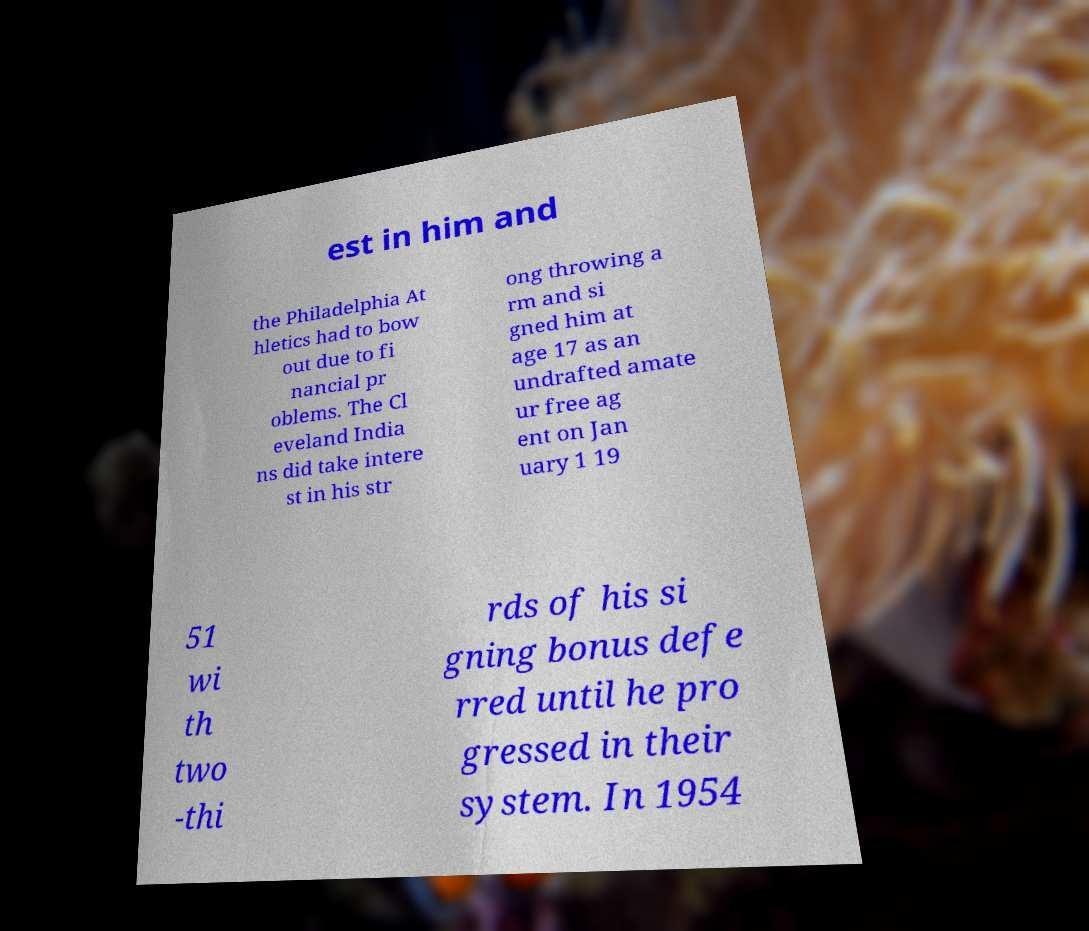I need the written content from this picture converted into text. Can you do that? est in him and the Philadelphia At hletics had to bow out due to fi nancial pr oblems. The Cl eveland India ns did take intere st in his str ong throwing a rm and si gned him at age 17 as an undrafted amate ur free ag ent on Jan uary 1 19 51 wi th two -thi rds of his si gning bonus defe rred until he pro gressed in their system. In 1954 